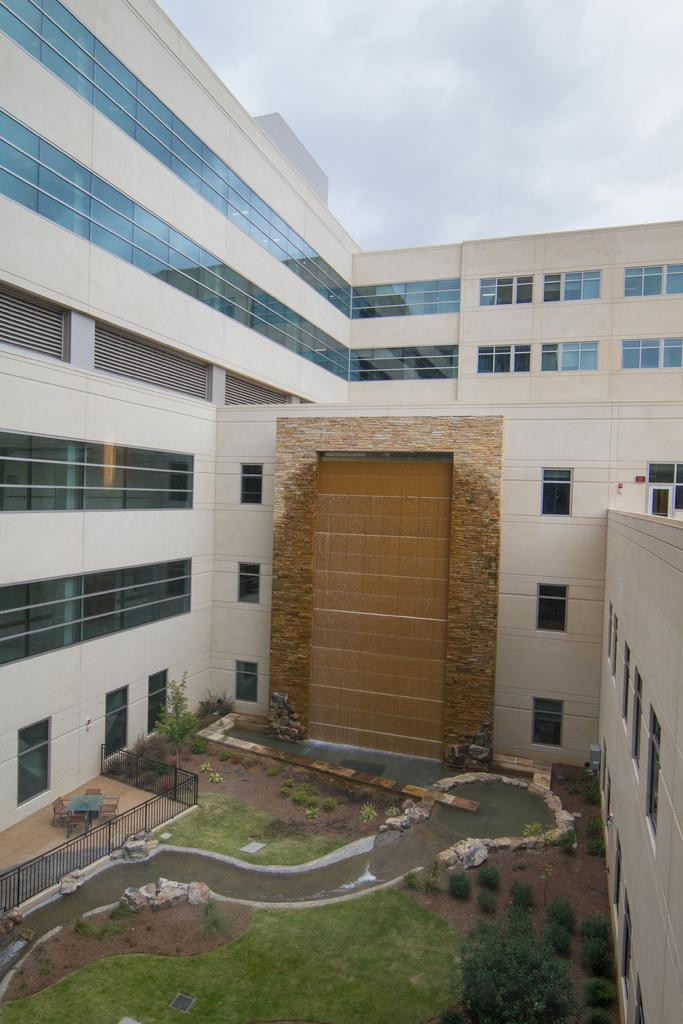What type of structures can be seen in the image? There are buildings in the image. What architectural features can be observed on the buildings? There are windows visible on the buildings. What type of vegetation is present in the image? There are trees and grass in the image. What is the boundary between the grass and the buildings? There is a fence in the image. What natural element is visible in the image? Water is visible in the image. What is visible at the top of the image? The sky is visible at the top of the image. What is the income of the beetle crawling on the fence in the image? There is no beetle present in the image, and therefore no income can be attributed to it. How does the sky in the image affect the income of the trees? The sky in the image does not affect the income of the trees, as the image does not provide any information about the trees' income or the sky's impact on it. 